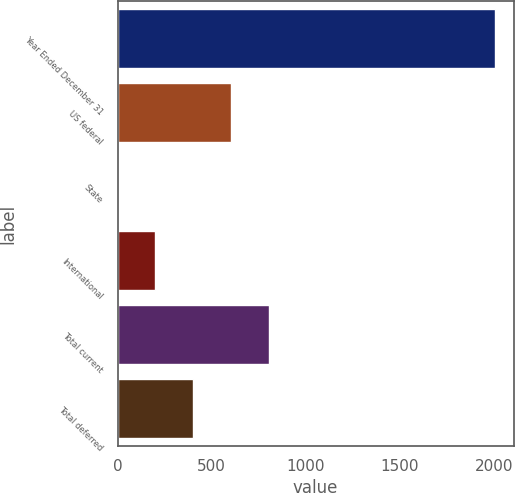Convert chart. <chart><loc_0><loc_0><loc_500><loc_500><bar_chart><fcel>Year Ended December 31<fcel>US federal<fcel>State<fcel>International<fcel>Total current<fcel>Total deferred<nl><fcel>2003<fcel>601.6<fcel>1<fcel>201.2<fcel>801.8<fcel>401.4<nl></chart> 